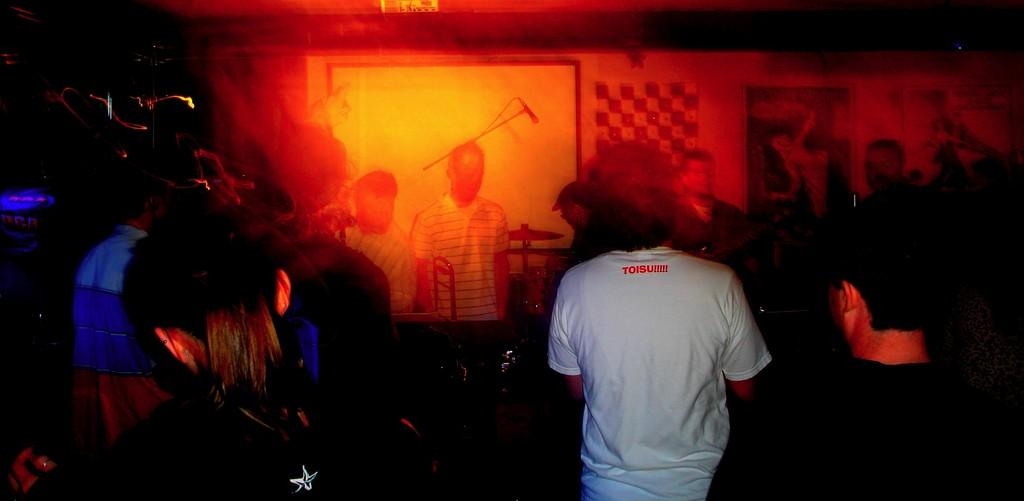What can be observed about the lighting in the image? The corners of the image are dark. What is happening in the image? There are people in the image, and they are standing. What are the people wearing? The people are wearing clothes. What object related to sound is present in the image? There is a microphone in the image. What type of objects can be seen that are typically used for making music? There are musical instruments in the image. Can you tell me what the grandmother is doing in the image? There is no grandmother present in the image. What type of appliance can be seen in the image? There is no appliance visible in the image. 